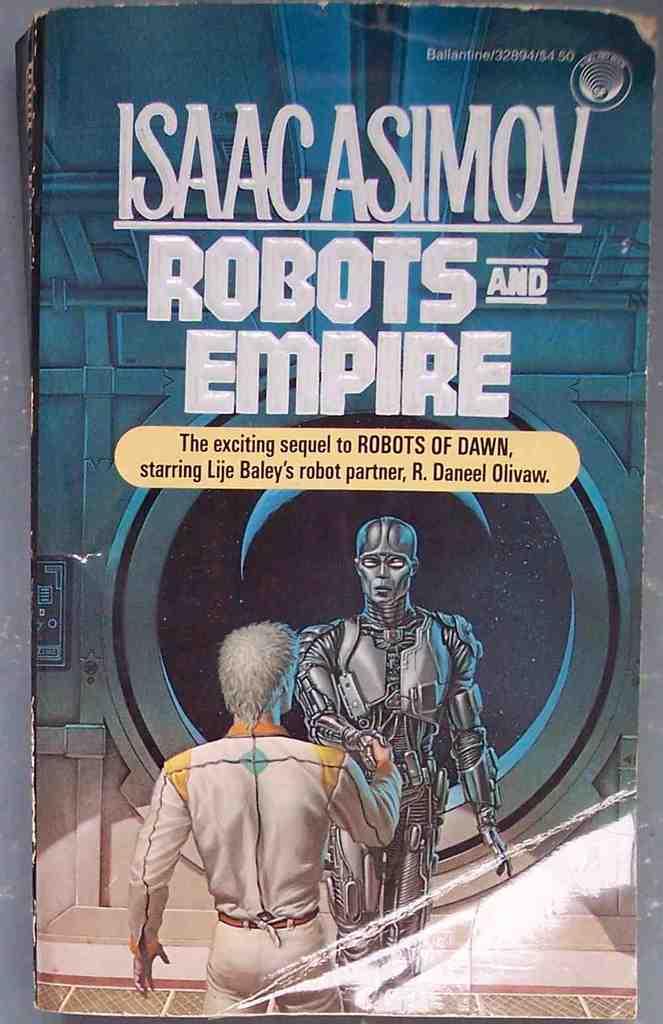What is this book a sequel to?
Your answer should be compact. Robots of dawn. Who is the author?
Your answer should be very brief. Isaac asimov. 